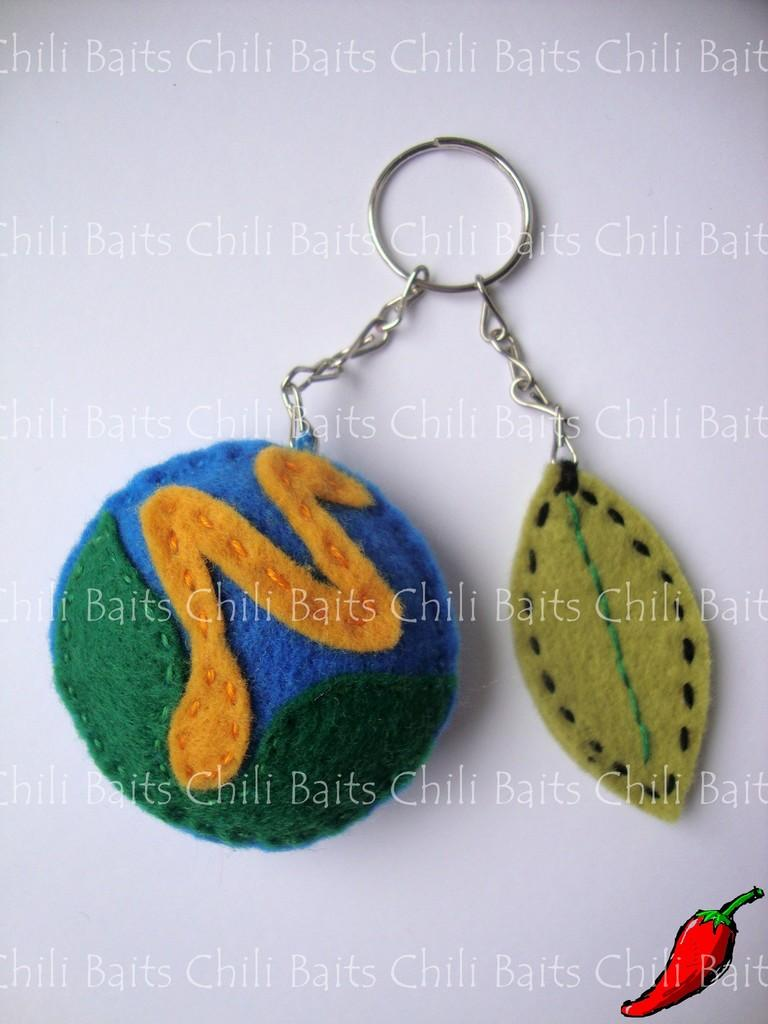What is the main subject of the image? The main subject of the image is a keychain. Can you describe the keychain in more detail? Yes, there is text and a logo on the keychain. Is there a veil covering the keychain in the image? No, there is no veil present in the image. Can you see a stream flowing in the background of the image? No, there is no stream visible in the image. 